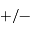<formula> <loc_0><loc_0><loc_500><loc_500>+ / -</formula> 